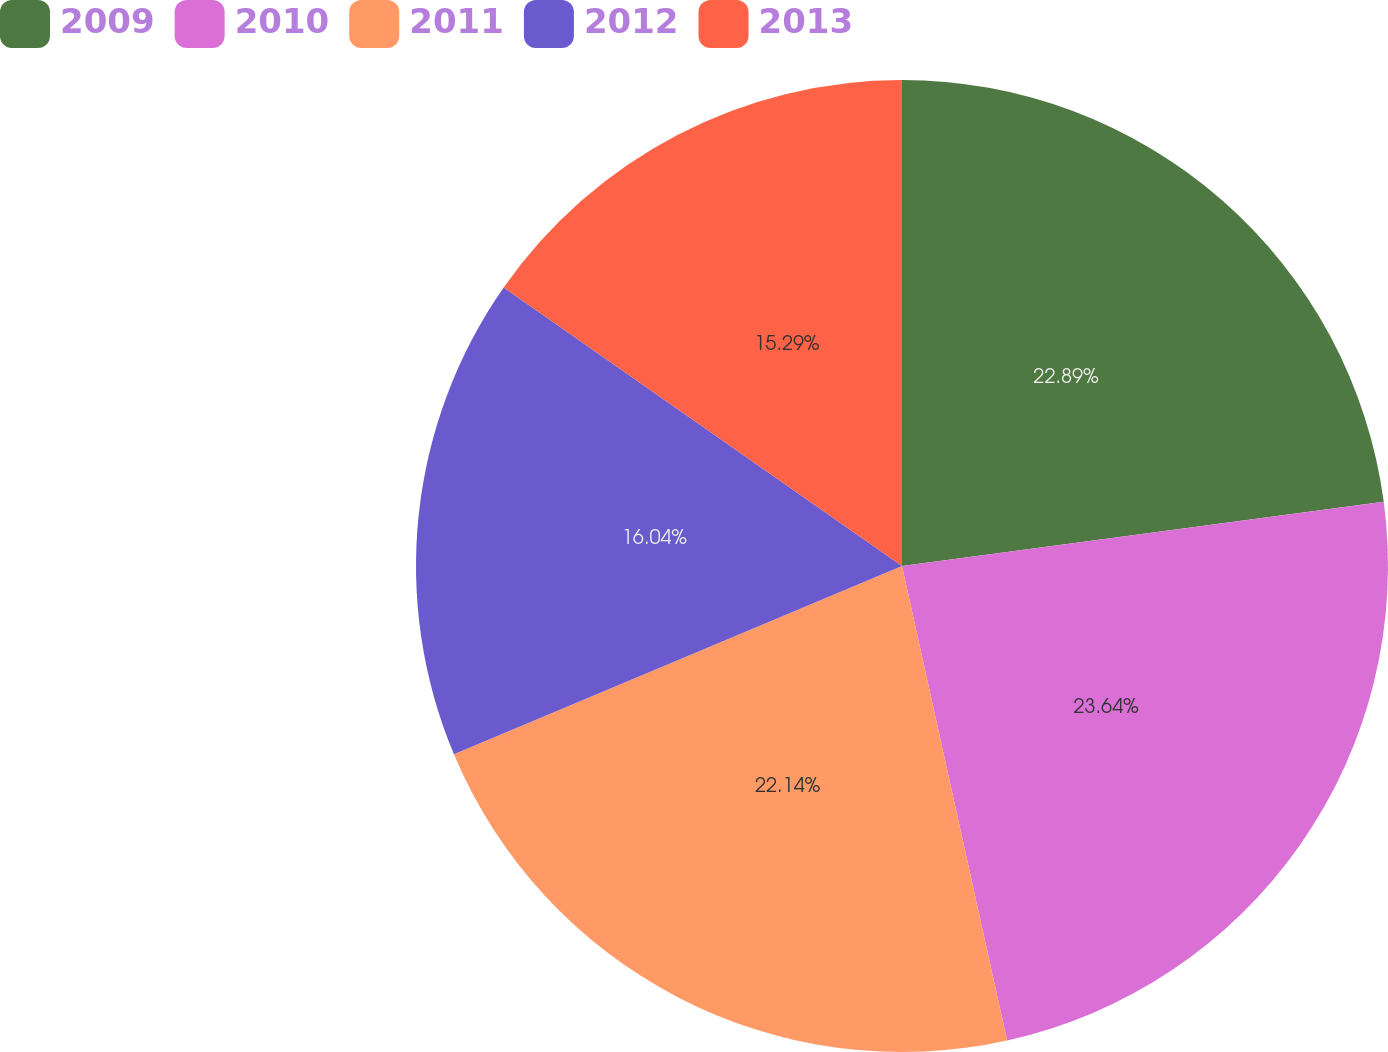Convert chart. <chart><loc_0><loc_0><loc_500><loc_500><pie_chart><fcel>2009<fcel>2010<fcel>2011<fcel>2012<fcel>2013<nl><fcel>22.89%<fcel>23.64%<fcel>22.14%<fcel>16.04%<fcel>15.29%<nl></chart> 